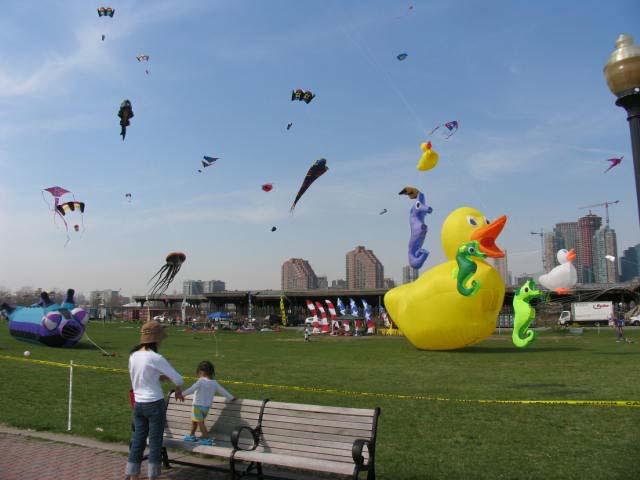Are the people in the picture male?
Write a very short answer. No. What is in the birds mouth?
Concise answer only. Nothing. Who put that rubber ducky in there?
Short answer required. People. Why did they paint it yellow?
Quick response, please. Rubber ducks are yellow. What is that big yellow thing?
Answer briefly. Duck. Do you see a pink seahorse?
Quick response, please. No. How many seagulls are on the bench?
Give a very brief answer. 0. 